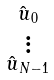Convert formula to latex. <formula><loc_0><loc_0><loc_500><loc_500>\begin{smallmatrix} \hat { u } _ { 0 } \\ \vdots \\ \hat { u } _ { N - 1 } \end{smallmatrix}</formula> 